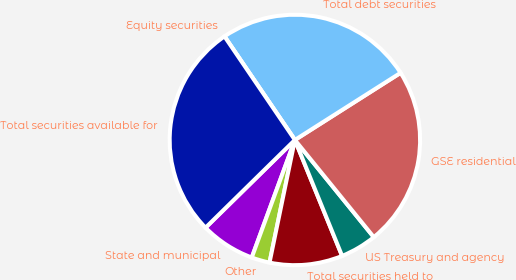<chart> <loc_0><loc_0><loc_500><loc_500><pie_chart><fcel>State and municipal<fcel>Other<fcel>Total securities held to<fcel>US Treasury and agency<fcel>GSE residential<fcel>Total debt securities<fcel>Equity securities<fcel>Total securities available for<nl><fcel>7.05%<fcel>2.35%<fcel>9.4%<fcel>4.7%<fcel>23.15%<fcel>25.5%<fcel>0.0%<fcel>27.85%<nl></chart> 